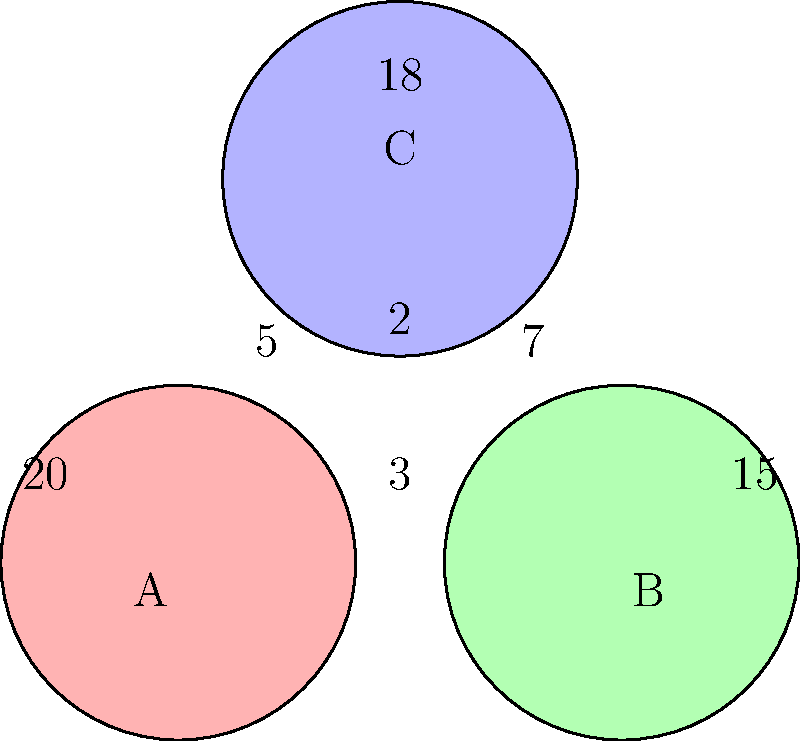In the Venn diagram above, three competing captioning software products (A, B, and C) are represented. The numbers in each region indicate the number of unique features for each product or combination of products. How many features are shared by all three captioning software products? To find the number of features shared by all three captioning software products, we need to follow these steps:

1. Understand the Venn diagram:
   - Each circle represents a captioning software product (A, B, and C).
   - The numbers in each region represent unique features or shared features.

2. Identify the region where all three circles overlap:
   - This is the central region where all three circles intersect.

3. Read the number in the central region:
   - The number in the central region is 2.

4. Interpret the result:
   - The number 2 in the central region indicates that there are 2 features shared by all three captioning software products.

Therefore, the number of features shared by all three captioning software products is 2.
Answer: 2 